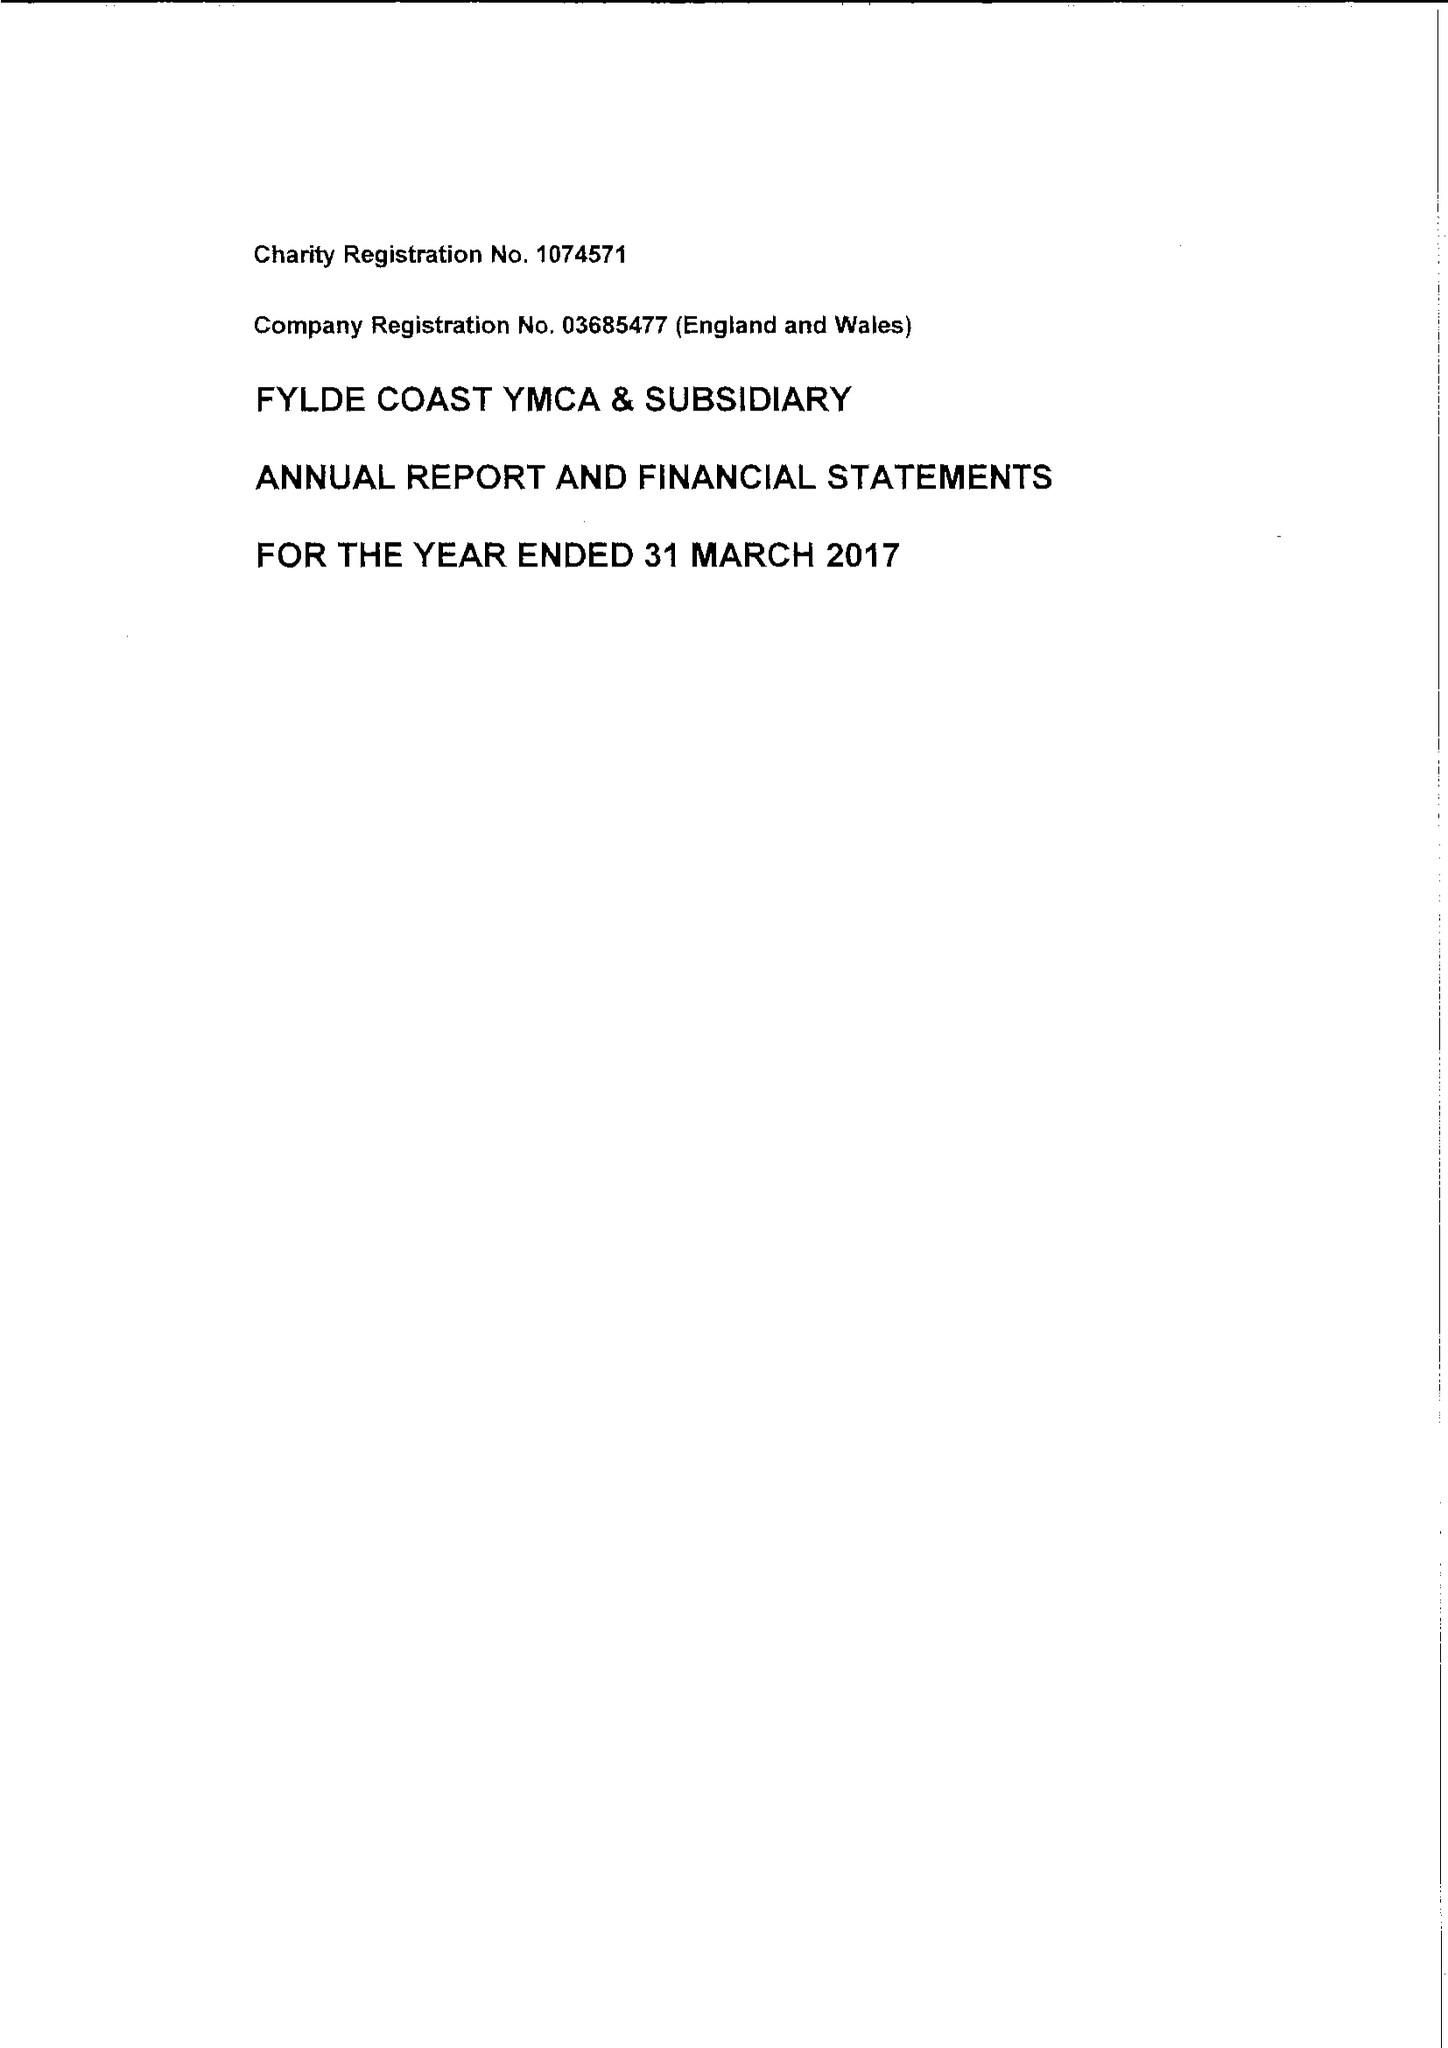What is the value for the address__post_town?
Answer the question using a single word or phrase. LYTHAM ST. ANNES 